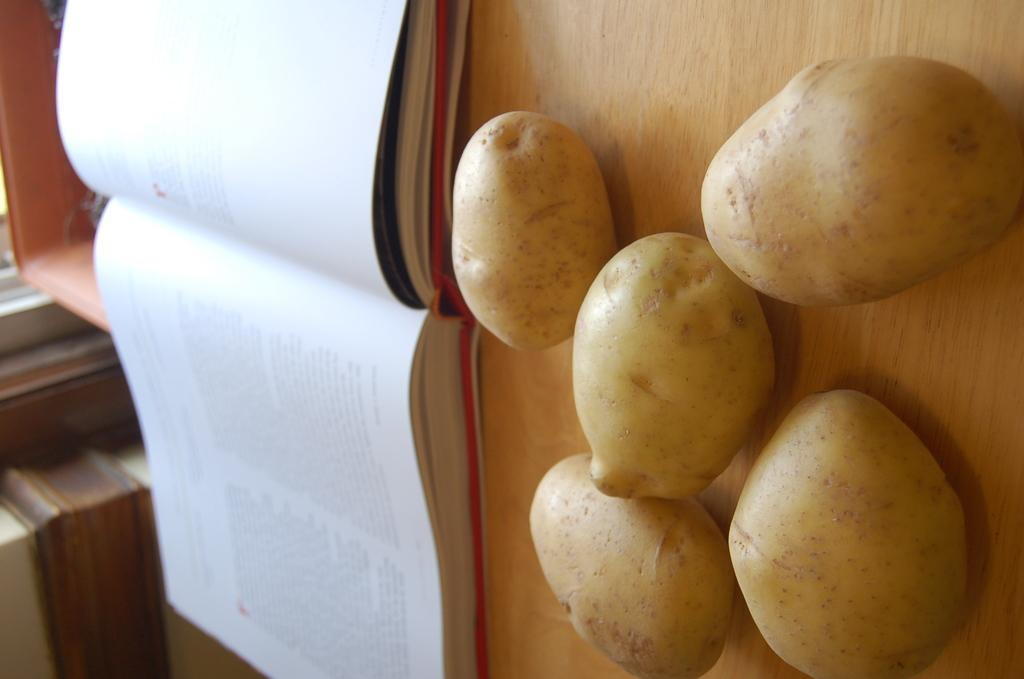What is open in the image? There is a book opened in the image. Where is the book located? The book is on a wooden table. What else is on the wooden table? There are potatoes placed on the wooden table. What type of science experiment is being conducted on the bed in the image? There is no bed or science experiment present in the image. 